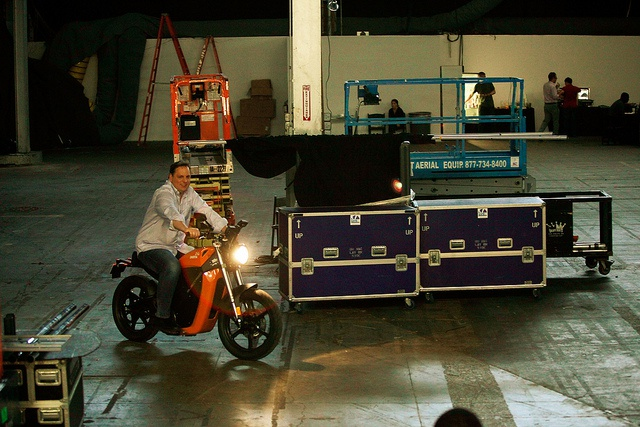Describe the objects in this image and their specific colors. I can see motorcycle in black, maroon, gray, and olive tones, people in black, tan, and gray tones, people in black and gray tones, people in black, darkgreen, and gray tones, and people in black, olive, maroon, and tan tones in this image. 